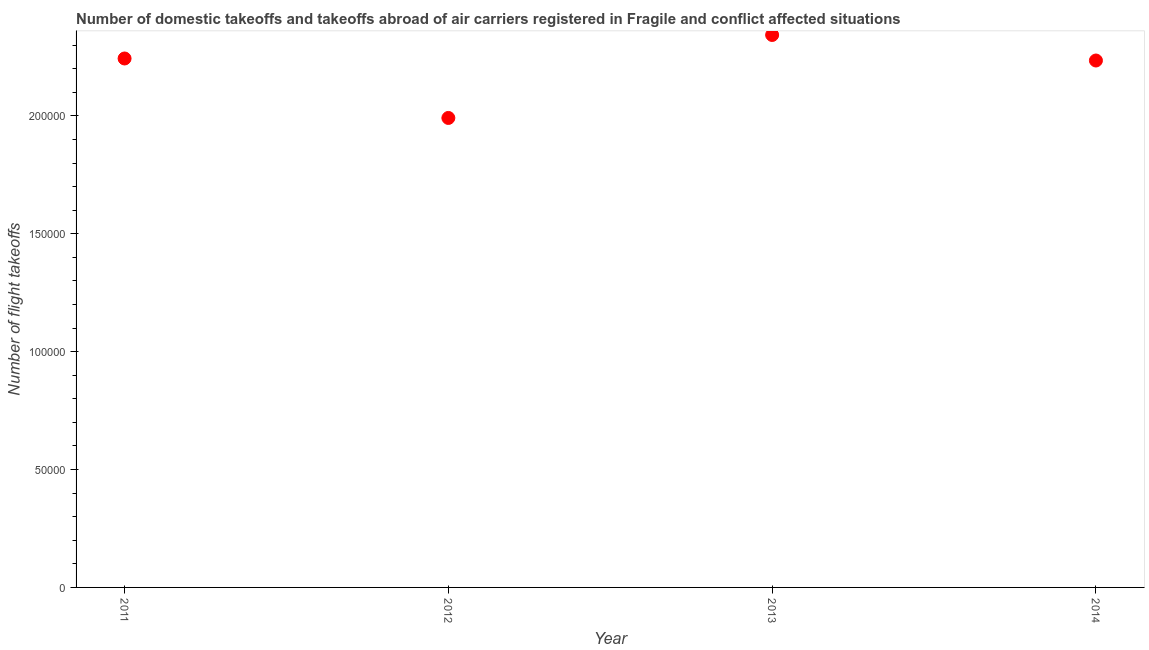What is the number of flight takeoffs in 2013?
Ensure brevity in your answer.  2.34e+05. Across all years, what is the maximum number of flight takeoffs?
Offer a terse response. 2.34e+05. Across all years, what is the minimum number of flight takeoffs?
Your response must be concise. 1.99e+05. In which year was the number of flight takeoffs maximum?
Offer a very short reply. 2013. What is the sum of the number of flight takeoffs?
Your answer should be very brief. 8.81e+05. What is the difference between the number of flight takeoffs in 2013 and 2014?
Offer a very short reply. 1.08e+04. What is the average number of flight takeoffs per year?
Your answer should be very brief. 2.20e+05. What is the median number of flight takeoffs?
Ensure brevity in your answer.  2.24e+05. In how many years, is the number of flight takeoffs greater than 50000 ?
Your answer should be compact. 4. What is the ratio of the number of flight takeoffs in 2011 to that in 2014?
Provide a succinct answer. 1. What is the difference between the highest and the second highest number of flight takeoffs?
Your answer should be very brief. 9973.8. What is the difference between the highest and the lowest number of flight takeoffs?
Offer a terse response. 3.52e+04. Does the number of flight takeoffs monotonically increase over the years?
Make the answer very short. No. How many dotlines are there?
Provide a short and direct response. 1. What is the difference between two consecutive major ticks on the Y-axis?
Ensure brevity in your answer.  5.00e+04. Does the graph contain any zero values?
Provide a succinct answer. No. What is the title of the graph?
Provide a short and direct response. Number of domestic takeoffs and takeoffs abroad of air carriers registered in Fragile and conflict affected situations. What is the label or title of the Y-axis?
Provide a succinct answer. Number of flight takeoffs. What is the Number of flight takeoffs in 2011?
Ensure brevity in your answer.  2.24e+05. What is the Number of flight takeoffs in 2012?
Your response must be concise. 1.99e+05. What is the Number of flight takeoffs in 2013?
Give a very brief answer. 2.34e+05. What is the Number of flight takeoffs in 2014?
Make the answer very short. 2.24e+05. What is the difference between the Number of flight takeoffs in 2011 and 2012?
Ensure brevity in your answer.  2.52e+04. What is the difference between the Number of flight takeoffs in 2011 and 2013?
Offer a terse response. -9973.8. What is the difference between the Number of flight takeoffs in 2011 and 2014?
Give a very brief answer. 860.98. What is the difference between the Number of flight takeoffs in 2012 and 2013?
Your response must be concise. -3.52e+04. What is the difference between the Number of flight takeoffs in 2012 and 2014?
Offer a terse response. -2.44e+04. What is the difference between the Number of flight takeoffs in 2013 and 2014?
Give a very brief answer. 1.08e+04. What is the ratio of the Number of flight takeoffs in 2011 to that in 2012?
Your answer should be compact. 1.13. What is the ratio of the Number of flight takeoffs in 2011 to that in 2013?
Ensure brevity in your answer.  0.96. What is the ratio of the Number of flight takeoffs in 2011 to that in 2014?
Ensure brevity in your answer.  1. What is the ratio of the Number of flight takeoffs in 2012 to that in 2014?
Your answer should be compact. 0.89. What is the ratio of the Number of flight takeoffs in 2013 to that in 2014?
Provide a succinct answer. 1.05. 